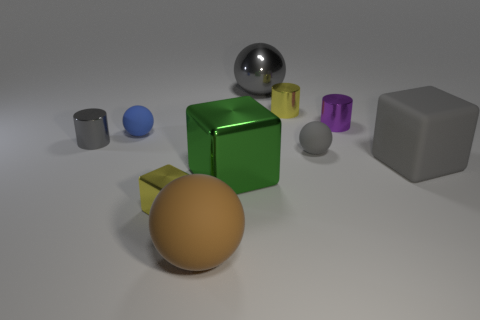Subtract all brown spheres. How many spheres are left? 3 Subtract all blue balls. How many balls are left? 3 Subtract 1 spheres. How many spheres are left? 3 Subtract all green balls. Subtract all green cubes. How many balls are left? 4 Subtract all cylinders. How many objects are left? 7 Subtract all large gray matte things. Subtract all gray shiny balls. How many objects are left? 8 Add 8 brown matte objects. How many brown matte objects are left? 9 Add 5 small blue metallic cylinders. How many small blue metallic cylinders exist? 5 Subtract 0 blue blocks. How many objects are left? 10 